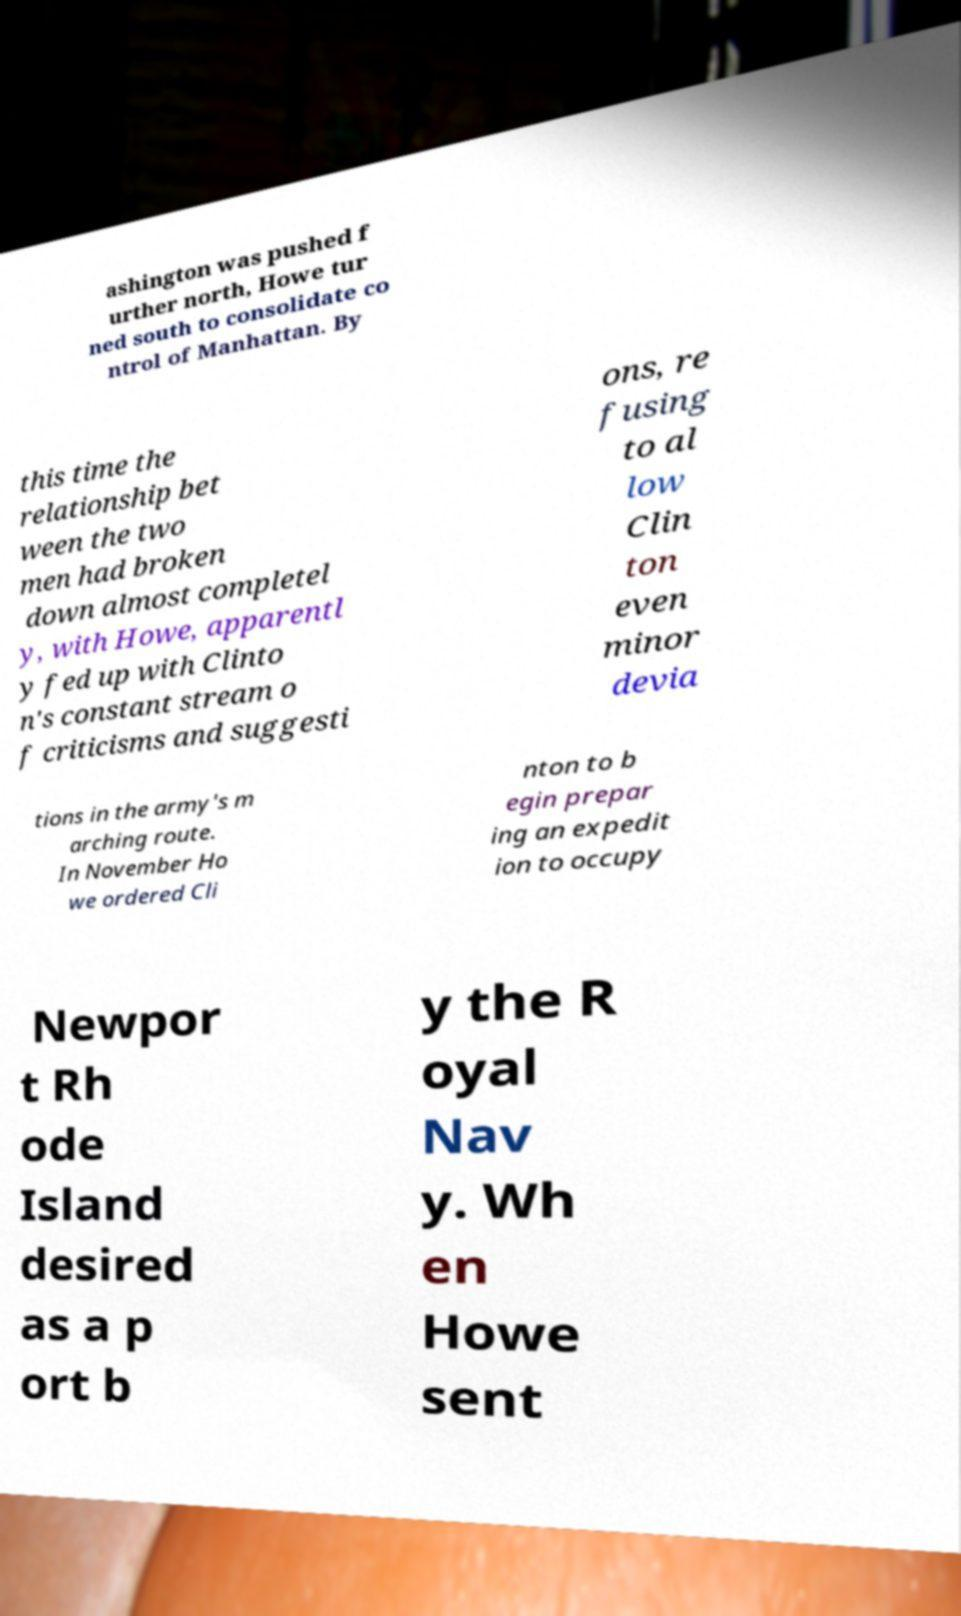Can you accurately transcribe the text from the provided image for me? ashington was pushed f urther north, Howe tur ned south to consolidate co ntrol of Manhattan. By this time the relationship bet ween the two men had broken down almost completel y, with Howe, apparentl y fed up with Clinto n's constant stream o f criticisms and suggesti ons, re fusing to al low Clin ton even minor devia tions in the army's m arching route. In November Ho we ordered Cli nton to b egin prepar ing an expedit ion to occupy Newpor t Rh ode Island desired as a p ort b y the R oyal Nav y. Wh en Howe sent 